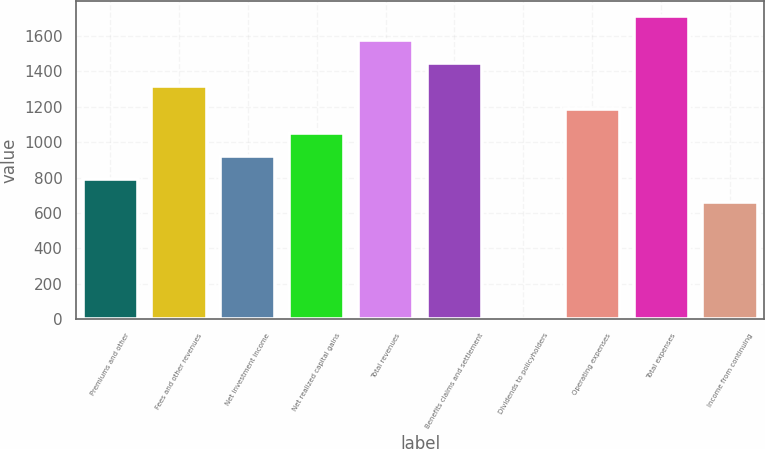Convert chart to OTSL. <chart><loc_0><loc_0><loc_500><loc_500><bar_chart><fcel>Premiums and other<fcel>Fees and other revenues<fcel>Net investment income<fcel>Net realized capital gains<fcel>Total revenues<fcel>Benefits claims and settlement<fcel>Dividends to policyholders<fcel>Operating expenses<fcel>Total expenses<fcel>Income from continuing<nl><fcel>791.14<fcel>1316.5<fcel>922.48<fcel>1053.82<fcel>1579.18<fcel>1447.84<fcel>3.1<fcel>1185.16<fcel>1710.52<fcel>659.8<nl></chart> 